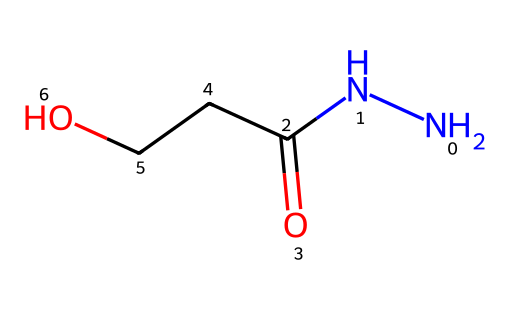How many nitrogen atoms are in this structure? By examining the SMILES representation, there are two 'N' characters indicating the presence of two nitrogen atoms in the structure.
Answer: 2 What functional group is present in this compound? The 'NC(=O)' portion of the SMILES indicates a carbonyl group bonded to a nitrogen atom, characterizing it as an amide due to the connection of the carbon to the nitrogen.
Answer: amide What type of chemical reaction could hydrazine derivatives like this facilitate in leather tanning? The amide structure can participate in condensation reactions during leather tanning, where it may react with other substances to form cross-links, making the leather more durable.
Answer: condensation How many carbon atoms are in this compound? The SMILES representation shows 'CC' next to 'C(=O)', suggesting that there are two carbon atoms along with one connected to the carbonyl, totaling three carbon atoms.
Answer: 3 What is the significance of the hydrazine aspect in this compound? The presence of the two nitrogen atoms linked to each other indicates an important characteristic of hydrazines, which is their potential to interact with various substrates in tanning processes, affecting properties such as flexibility and strength of the leather.
Answer: interaction potential What is the approximate molecular weight of this compound? To find the molecular weight, we sum the atomic weights of each atom in the structure: nitrogen (14), carbon (12), oxygen (16), and hydrogen (1). The total gives an approximate molecular weight around 74 g/mol.
Answer: 74 